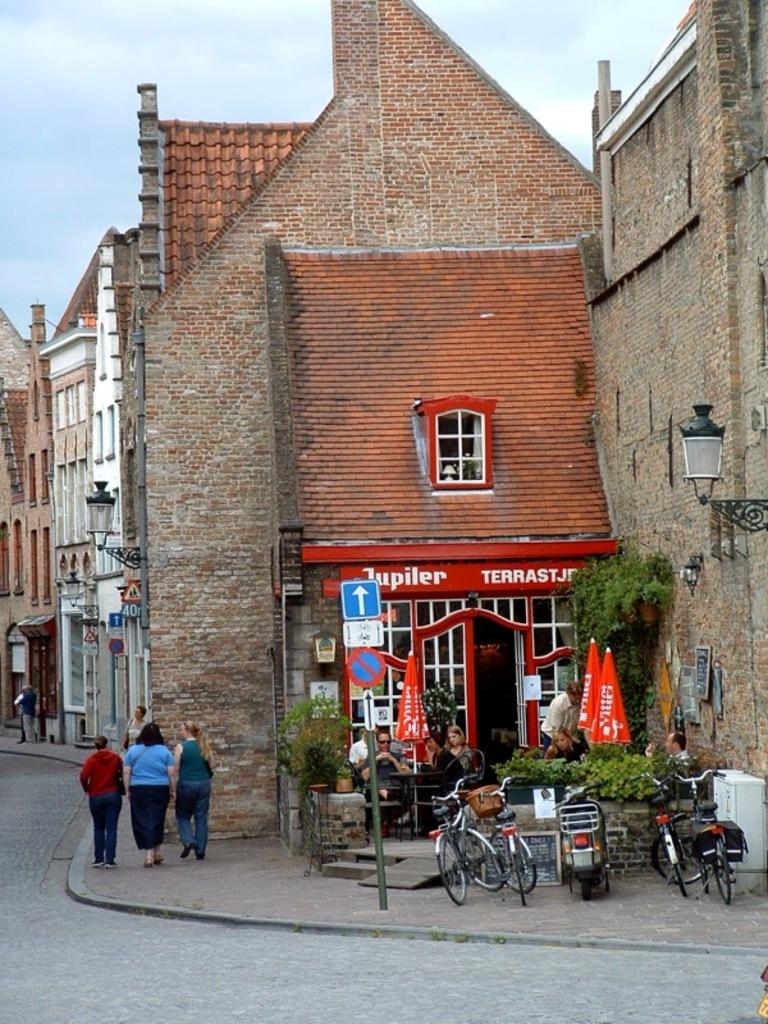<image>
Present a compact description of the photo's key features. an exterior of Jupiler restaurant with bikes parked outside 